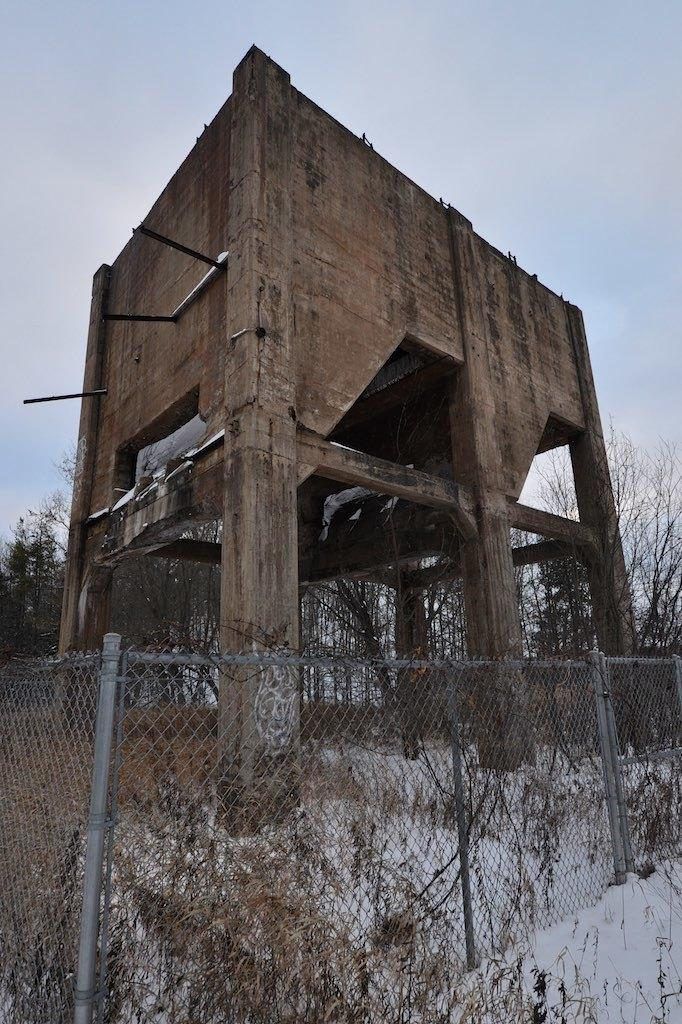What type of barrier is present in the image? There is a fence in the image. What can be seen behind the fence? Trees are visible behind the fence. What material is used to make the wooden object in the image? The wooden object in the image is made of wood. How would you describe the sky in the image? The sky is cloudy in the image. What type of silk fabric is draped over the fence in the image? There is no silk fabric present in the image; it features a fence, trees, and a wooden object. What scientific experiment is being conducted in the image? There is no scientific experiment depicted in the image. 